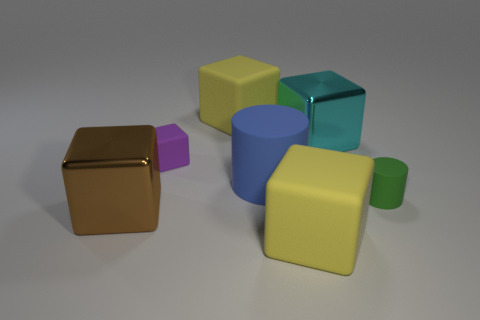Subtract all purple cubes. How many cubes are left? 4 Subtract all purple cubes. How many cubes are left? 4 Subtract 1 blocks. How many blocks are left? 4 Subtract all green cubes. Subtract all gray cylinders. How many cubes are left? 5 Add 3 brown cylinders. How many objects exist? 10 Subtract all cylinders. How many objects are left? 5 Subtract all large matte cylinders. Subtract all cyan objects. How many objects are left? 5 Add 7 purple things. How many purple things are left? 8 Add 4 small green blocks. How many small green blocks exist? 4 Subtract 0 yellow cylinders. How many objects are left? 7 